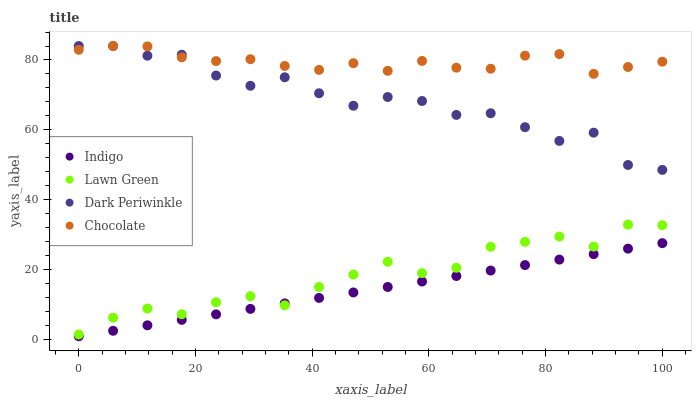Does Indigo have the minimum area under the curve?
Answer yes or no. Yes. Does Chocolate have the maximum area under the curve?
Answer yes or no. Yes. Does Dark Periwinkle have the minimum area under the curve?
Answer yes or no. No. Does Dark Periwinkle have the maximum area under the curve?
Answer yes or no. No. Is Indigo the smoothest?
Answer yes or no. Yes. Is Dark Periwinkle the roughest?
Answer yes or no. Yes. Is Dark Periwinkle the smoothest?
Answer yes or no. No. Is Indigo the roughest?
Answer yes or no. No. Does Indigo have the lowest value?
Answer yes or no. Yes. Does Dark Periwinkle have the lowest value?
Answer yes or no. No. Does Chocolate have the highest value?
Answer yes or no. Yes. Does Indigo have the highest value?
Answer yes or no. No. Is Indigo less than Chocolate?
Answer yes or no. Yes. Is Chocolate greater than Indigo?
Answer yes or no. Yes. Does Chocolate intersect Dark Periwinkle?
Answer yes or no. Yes. Is Chocolate less than Dark Periwinkle?
Answer yes or no. No. Is Chocolate greater than Dark Periwinkle?
Answer yes or no. No. Does Indigo intersect Chocolate?
Answer yes or no. No. 